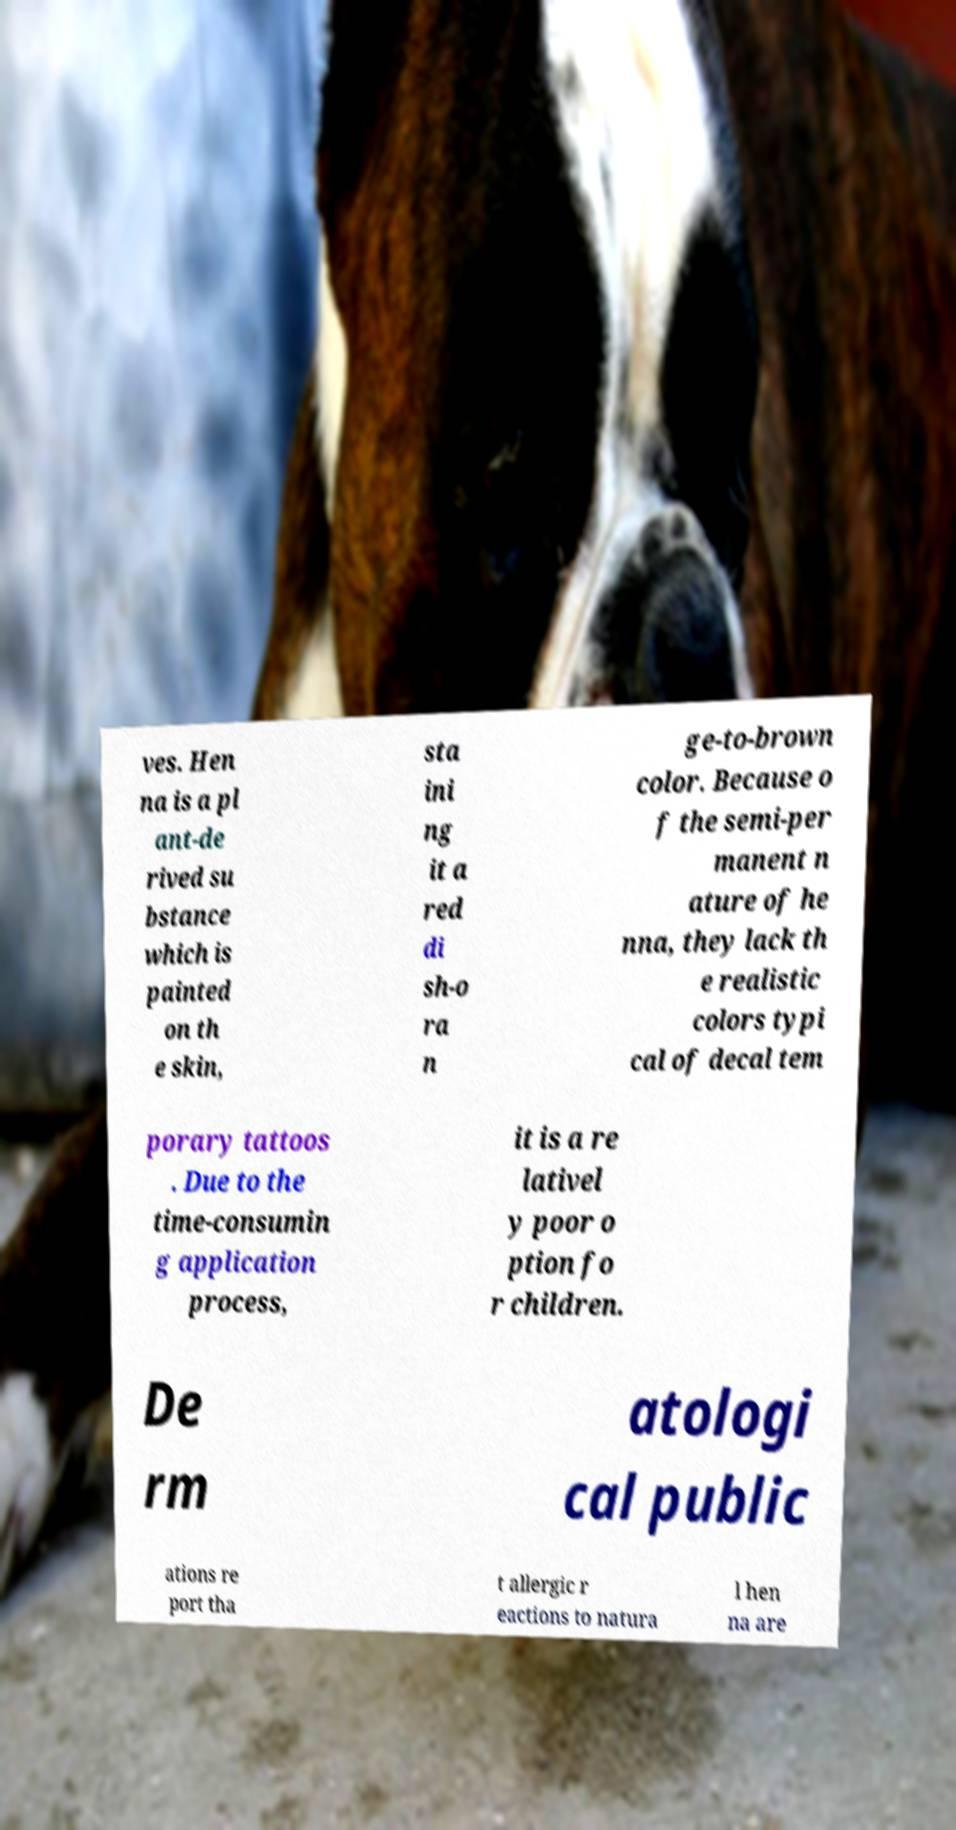Please identify and transcribe the text found in this image. ves. Hen na is a pl ant-de rived su bstance which is painted on th e skin, sta ini ng it a red di sh-o ra n ge-to-brown color. Because o f the semi-per manent n ature of he nna, they lack th e realistic colors typi cal of decal tem porary tattoos . Due to the time-consumin g application process, it is a re lativel y poor o ption fo r children. De rm atologi cal public ations re port tha t allergic r eactions to natura l hen na are 